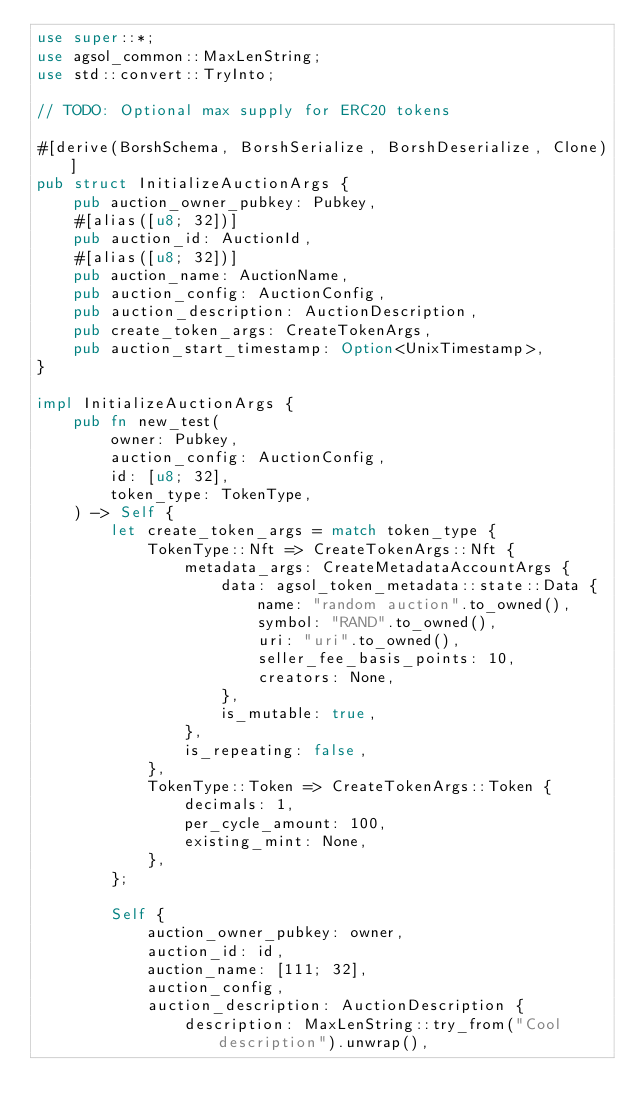Convert code to text. <code><loc_0><loc_0><loc_500><loc_500><_Rust_>use super::*;
use agsol_common::MaxLenString;
use std::convert::TryInto;

// TODO: Optional max supply for ERC20 tokens

#[derive(BorshSchema, BorshSerialize, BorshDeserialize, Clone)]
pub struct InitializeAuctionArgs {
    pub auction_owner_pubkey: Pubkey,
    #[alias([u8; 32])]
    pub auction_id: AuctionId,
    #[alias([u8; 32])]
    pub auction_name: AuctionName,
    pub auction_config: AuctionConfig,
    pub auction_description: AuctionDescription,
    pub create_token_args: CreateTokenArgs,
    pub auction_start_timestamp: Option<UnixTimestamp>,
}

impl InitializeAuctionArgs {
    pub fn new_test(
        owner: Pubkey,
        auction_config: AuctionConfig,
        id: [u8; 32],
        token_type: TokenType,
    ) -> Self {
        let create_token_args = match token_type {
            TokenType::Nft => CreateTokenArgs::Nft {
                metadata_args: CreateMetadataAccountArgs {
                    data: agsol_token_metadata::state::Data {
                        name: "random auction".to_owned(),
                        symbol: "RAND".to_owned(),
                        uri: "uri".to_owned(),
                        seller_fee_basis_points: 10,
                        creators: None,
                    },
                    is_mutable: true,
                },
                is_repeating: false,
            },
            TokenType::Token => CreateTokenArgs::Token {
                decimals: 1,
                per_cycle_amount: 100,
                existing_mint: None,
            },
        };

        Self {
            auction_owner_pubkey: owner,
            auction_id: id,
            auction_name: [111; 32],
            auction_config,
            auction_description: AuctionDescription {
                description: MaxLenString::try_from("Cool description").unwrap(),</code> 